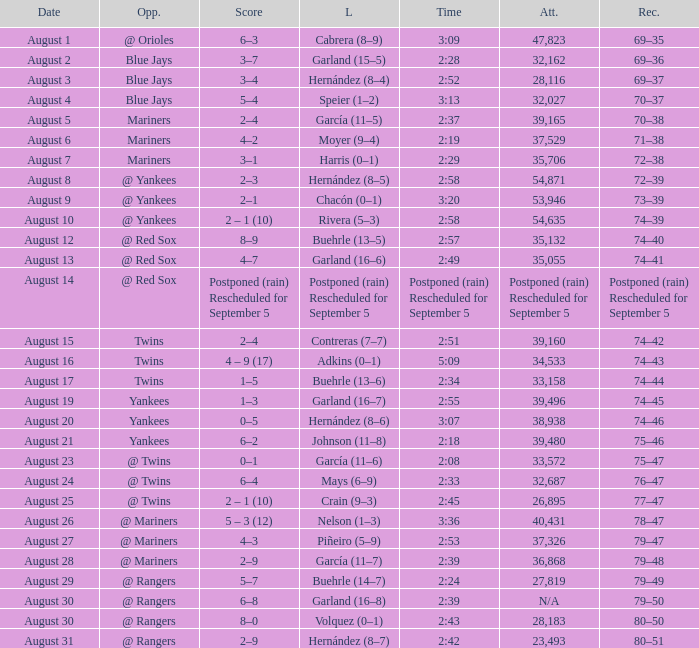Could you parse the entire table? {'header': ['Date', 'Opp.', 'Score', 'L', 'Time', 'Att.', 'Rec.'], 'rows': [['August 1', '@ Orioles', '6–3', 'Cabrera (8–9)', '3:09', '47,823', '69–35'], ['August 2', 'Blue Jays', '3–7', 'Garland (15–5)', '2:28', '32,162', '69–36'], ['August 3', 'Blue Jays', '3–4', 'Hernández (8–4)', '2:52', '28,116', '69–37'], ['August 4', 'Blue Jays', '5–4', 'Speier (1–2)', '3:13', '32,027', '70–37'], ['August 5', 'Mariners', '2–4', 'García (11–5)', '2:37', '39,165', '70–38'], ['August 6', 'Mariners', '4–2', 'Moyer (9–4)', '2:19', '37,529', '71–38'], ['August 7', 'Mariners', '3–1', 'Harris (0–1)', '2:29', '35,706', '72–38'], ['August 8', '@ Yankees', '2–3', 'Hernández (8–5)', '2:58', '54,871', '72–39'], ['August 9', '@ Yankees', '2–1', 'Chacón (0–1)', '3:20', '53,946', '73–39'], ['August 10', '@ Yankees', '2 – 1 (10)', 'Rivera (5–3)', '2:58', '54,635', '74–39'], ['August 12', '@ Red Sox', '8–9', 'Buehrle (13–5)', '2:57', '35,132', '74–40'], ['August 13', '@ Red Sox', '4–7', 'Garland (16–6)', '2:49', '35,055', '74–41'], ['August 14', '@ Red Sox', 'Postponed (rain) Rescheduled for September 5', 'Postponed (rain) Rescheduled for September 5', 'Postponed (rain) Rescheduled for September 5', 'Postponed (rain) Rescheduled for September 5', 'Postponed (rain) Rescheduled for September 5'], ['August 15', 'Twins', '2–4', 'Contreras (7–7)', '2:51', '39,160', '74–42'], ['August 16', 'Twins', '4 – 9 (17)', 'Adkins (0–1)', '5:09', '34,533', '74–43'], ['August 17', 'Twins', '1–5', 'Buehrle (13–6)', '2:34', '33,158', '74–44'], ['August 19', 'Yankees', '1–3', 'Garland (16–7)', '2:55', '39,496', '74–45'], ['August 20', 'Yankees', '0–5', 'Hernández (8–6)', '3:07', '38,938', '74–46'], ['August 21', 'Yankees', '6–2', 'Johnson (11–8)', '2:18', '39,480', '75–46'], ['August 23', '@ Twins', '0–1', 'García (11–6)', '2:08', '33,572', '75–47'], ['August 24', '@ Twins', '6–4', 'Mays (6–9)', '2:33', '32,687', '76–47'], ['August 25', '@ Twins', '2 – 1 (10)', 'Crain (9–3)', '2:45', '26,895', '77–47'], ['August 26', '@ Mariners', '5 – 3 (12)', 'Nelson (1–3)', '3:36', '40,431', '78–47'], ['August 27', '@ Mariners', '4–3', 'Piñeiro (5–9)', '2:53', '37,326', '79–47'], ['August 28', '@ Mariners', '2–9', 'García (11–7)', '2:39', '36,868', '79–48'], ['August 29', '@ Rangers', '5–7', 'Buehrle (14–7)', '2:24', '27,819', '79–49'], ['August 30', '@ Rangers', '6–8', 'Garland (16–8)', '2:39', 'N/A', '79–50'], ['August 30', '@ Rangers', '8–0', 'Volquez (0–1)', '2:43', '28,183', '80–50'], ['August 31', '@ Rangers', '2–9', 'Hernández (8–7)', '2:42', '23,493', '80–51']]} Who lost with a time of 2:42? Hernández (8–7). 